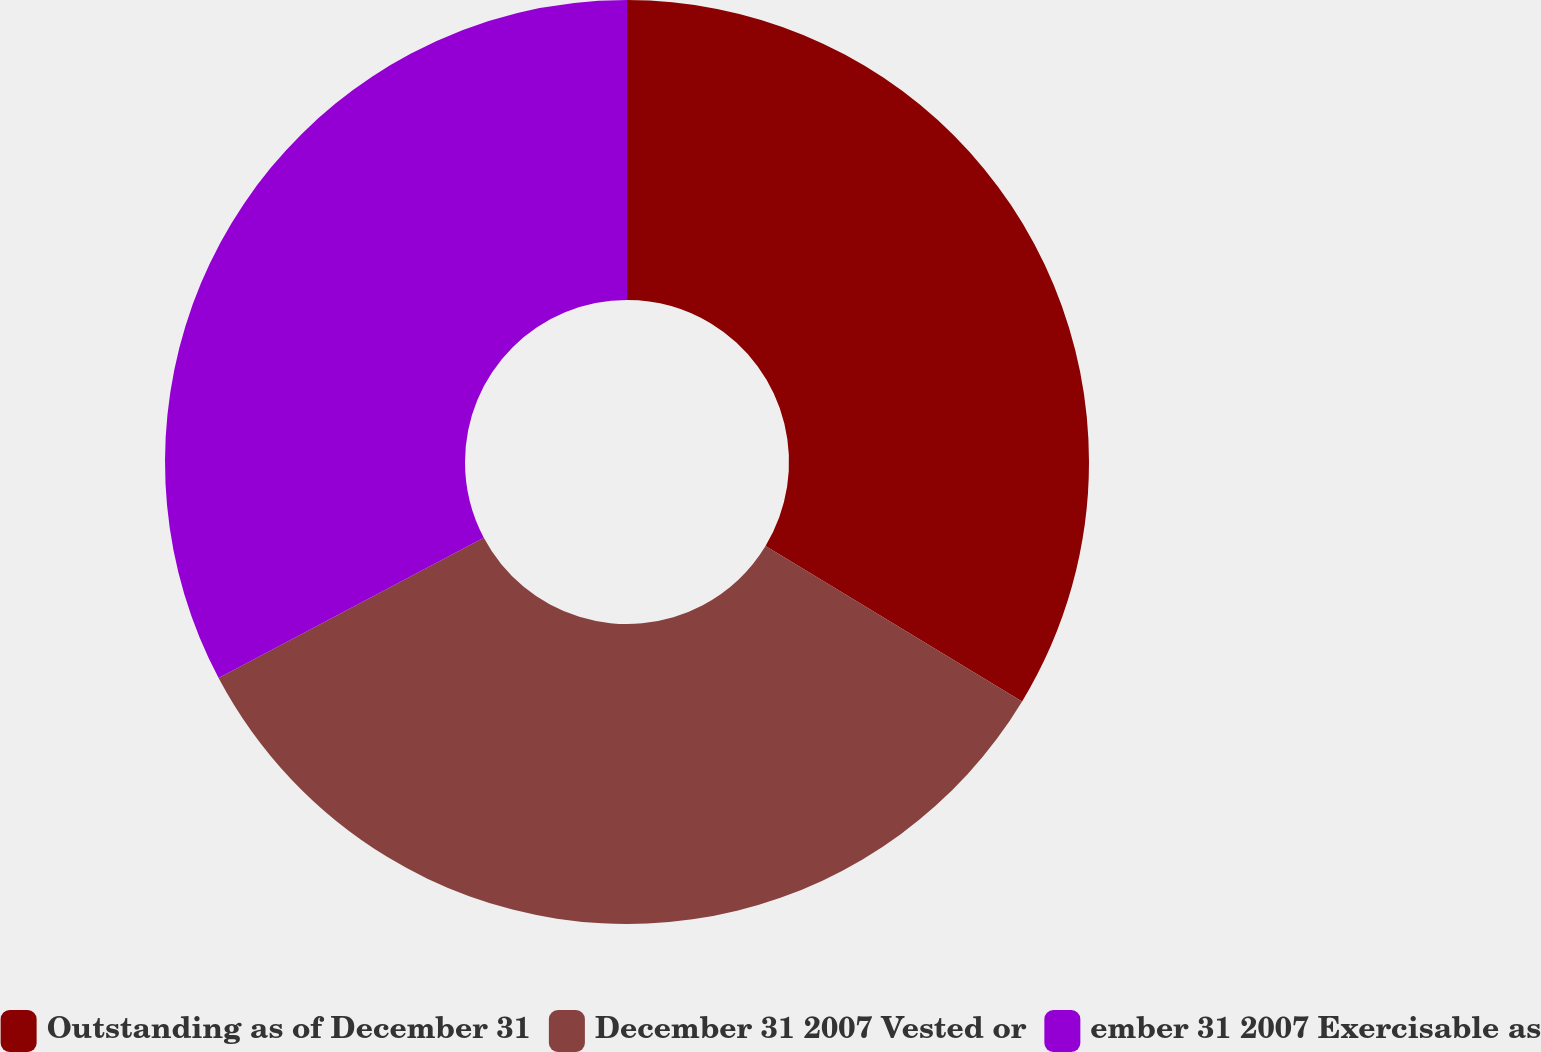<chart> <loc_0><loc_0><loc_500><loc_500><pie_chart><fcel>Outstanding as of December 31<fcel>December 31 2007 Vested or<fcel>ember 31 2007 Exercisable as<nl><fcel>33.67%<fcel>33.58%<fcel>32.74%<nl></chart> 